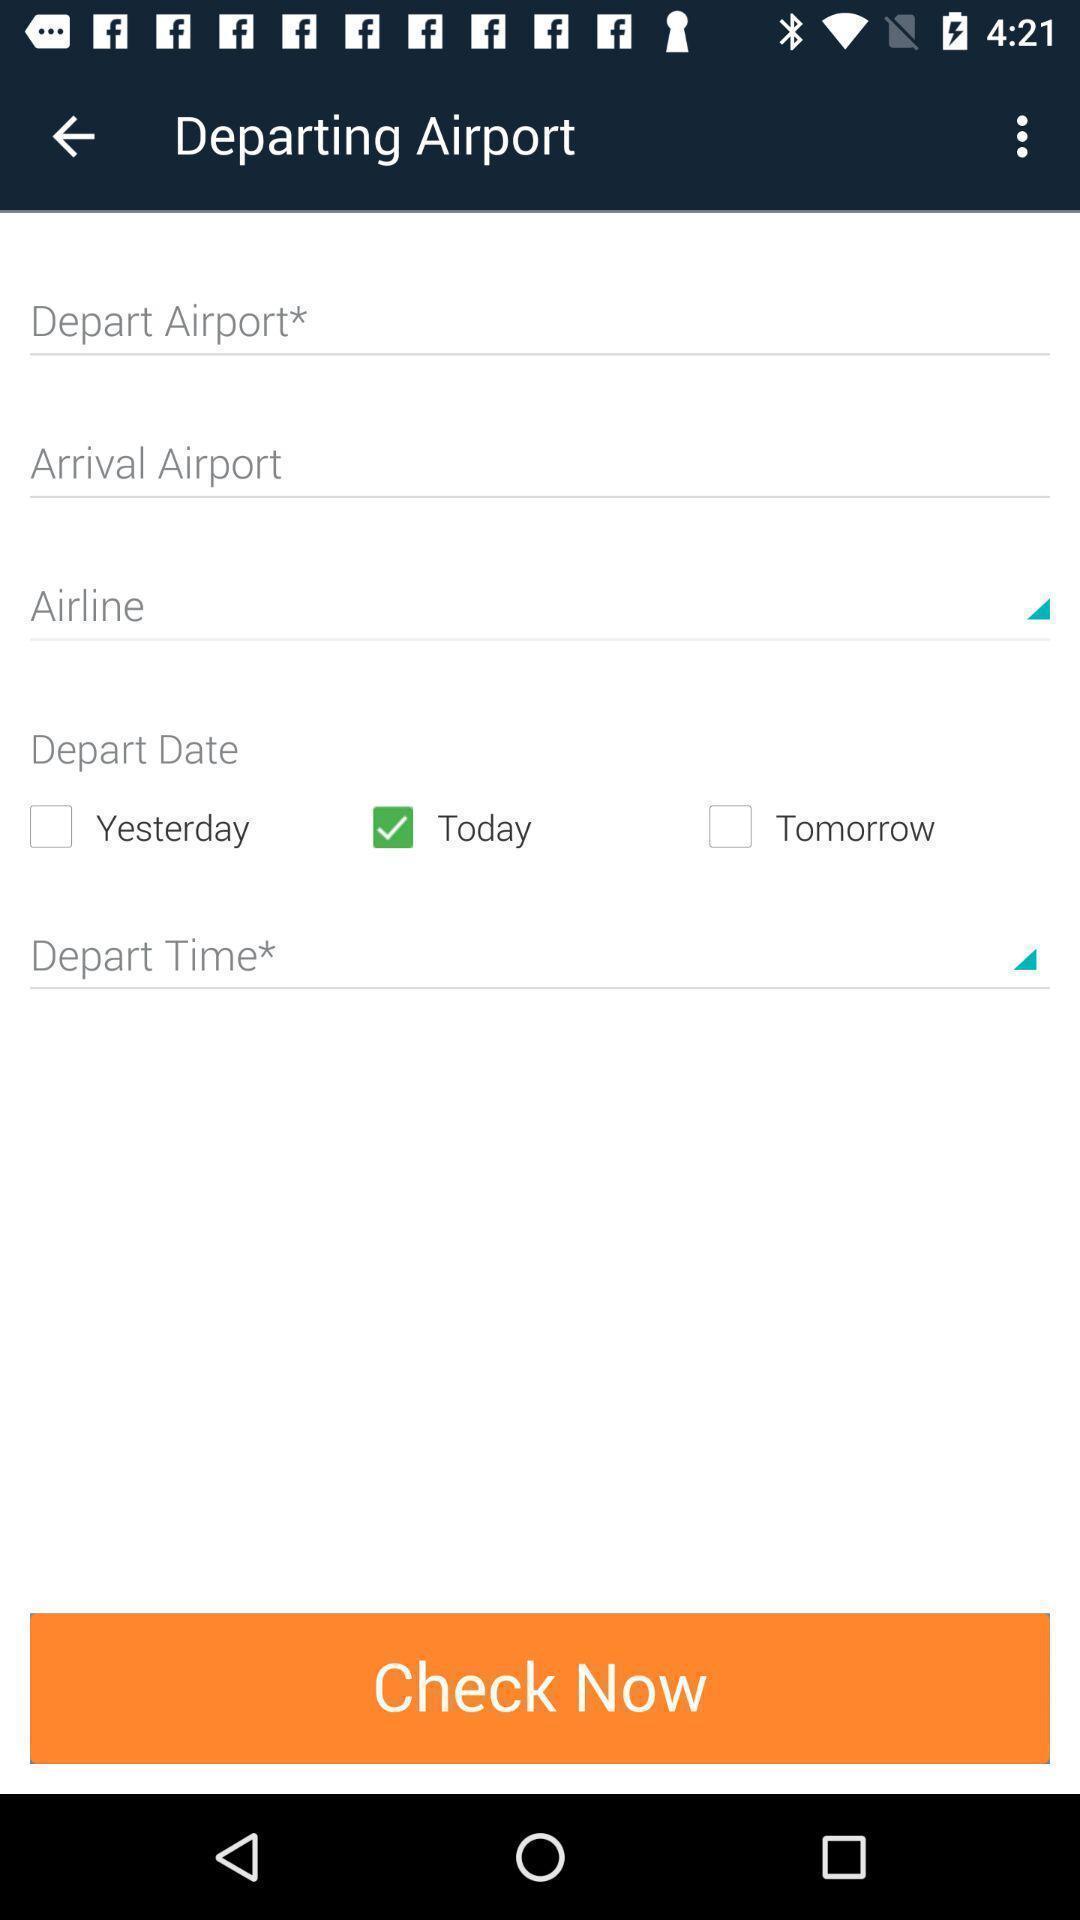Describe the key features of this screenshot. Page that displaying travel application. 